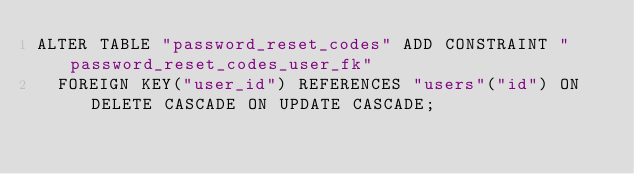<code> <loc_0><loc_0><loc_500><loc_500><_SQL_>ALTER TABLE "password_reset_codes" ADD CONSTRAINT "password_reset_codes_user_fk"
  FOREIGN KEY("user_id") REFERENCES "users"("id") ON DELETE CASCADE ON UPDATE CASCADE;
</code> 